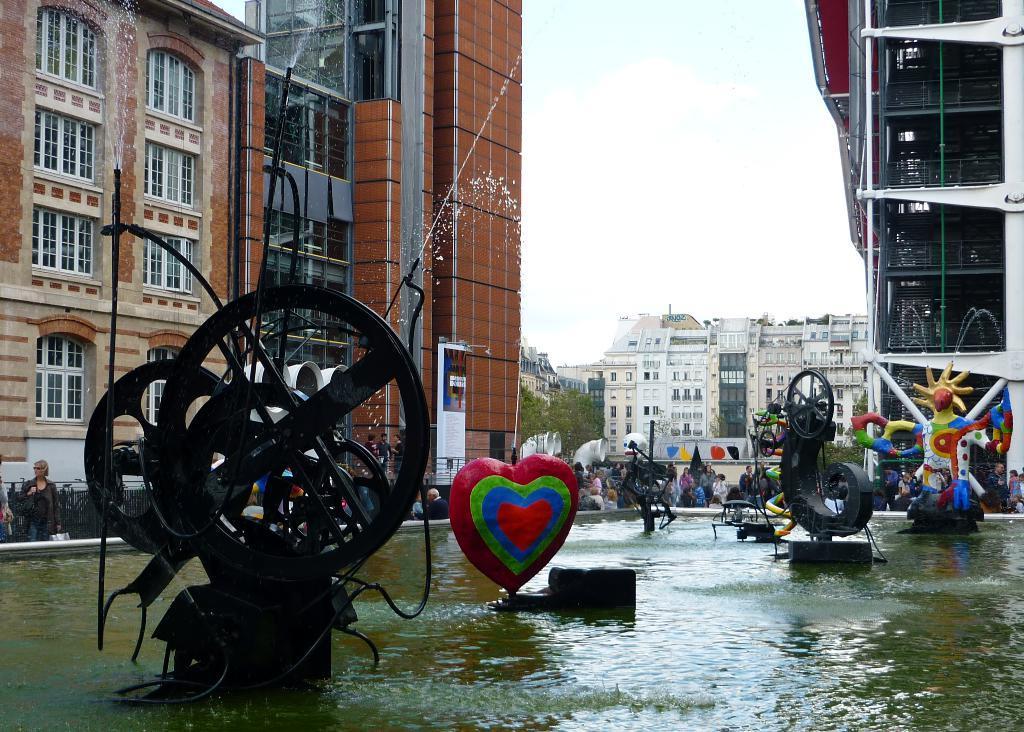Could you give a brief overview of what you see in this image? In this image we can see so many objects on the surface of water. We can see buildings, trees and people in the background and the sky at the top of the image. 